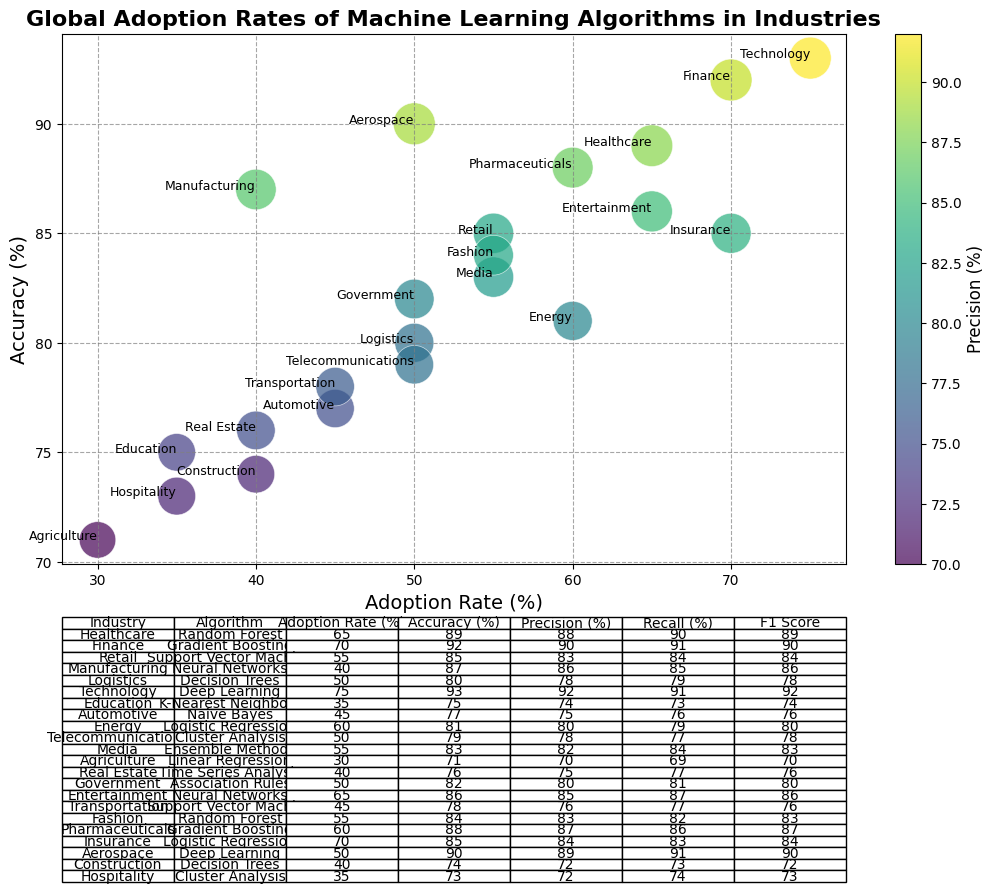What industry has the highest adoption rate of machine learning algorithms? By looking at the scatter plot, we can identify the data point located farthest to the right on the x-axis, which represents the highest adoption rate. This data point corresponds to the Technology industry, which has an adoption rate of 75%.
Answer: Technology Which machine learning algorithm has the highest precision, and which industry is it used in? From the colorbar and scatter points, the darkest point (indicating the highest precision) represents the Technology industry using Deep Learning with a precision of 92%.
Answer: Deep Learning in Technology What is the average adoption rate for industries using Neural Networks algorithms? Neural Networks are adopted by two industries: Manufacturing (40%) and Entertainment (65%). The average adoption rate is calculated as (40 + 65) / 2 = 52.5%.
Answer: 52.5% Which industry has the lowest accuracy and what is its corresponding adoption rate? By identifying the lowest point on the y-axis (accuracy), we find Agriculture with Linear Regression having an accuracy of 71% and an adoption rate of 30%.
Answer: Agriculture, 30% Among the industries using Support Vector Machine (SVM), which one has the higher adoption rate, and what is the difference between their adoption rates? Retail industry has an adoption rate of 55% and Transportation has 45%. The difference is 55% - 45% = 10%.
Answer: Retail, 10% What is the industry with both the highest adoption rate and accuracy? The scatter plot shows that the highest combination of adoption rate and accuracy is in the Technology industry utilizing Deep Learning, with an adoption rate of 75% and accuracy of 93%.
Answer: Technology with Deep Learning Compare the F1 Scores of Healthcare and Automotive industries. Which one is higher? Comparing the F1 Scores, Healthcare using Random Forest has an F1 Score of 89, while Automotive using Naive Bayes has an F1 Score of 76. Therefore, Healthcare has a higher F1 Score.
Answer: Healthcare Which industry has the highest recall, and what is its corresponding adoption rate? Checking the table for the highest recall value, the Healthcare industry using Random Forest has a recall of 90% and an adoption rate of 65%.
Answer: Healthcare, 65% What is the median accuracy of the listed industries? First, we list the accuracy values in ascending order: 71, 73, 74, 75 (twice), 76, 77 (twice), 78, 79 (twice), 80 (twice), 82, 83, 84 (twice), 85, 86, 87, 88, 89, 90, 92, 93. With 24 values, the median is the average of the 12th and 13th values: (79 + 80)/2 = 79.5.
Answer: 79.5 How does the relative size of the markers on the scatter plot correlate to the recall values, and which industry has the largest marker? The size of the markers in the scatter plot corresponds to the recall values multiplied by 10. The largest marker, therefore, corresponds to the highest recall value of Healthcare (90%), making it the industry with the largest marker.
Answer: Healthcare 